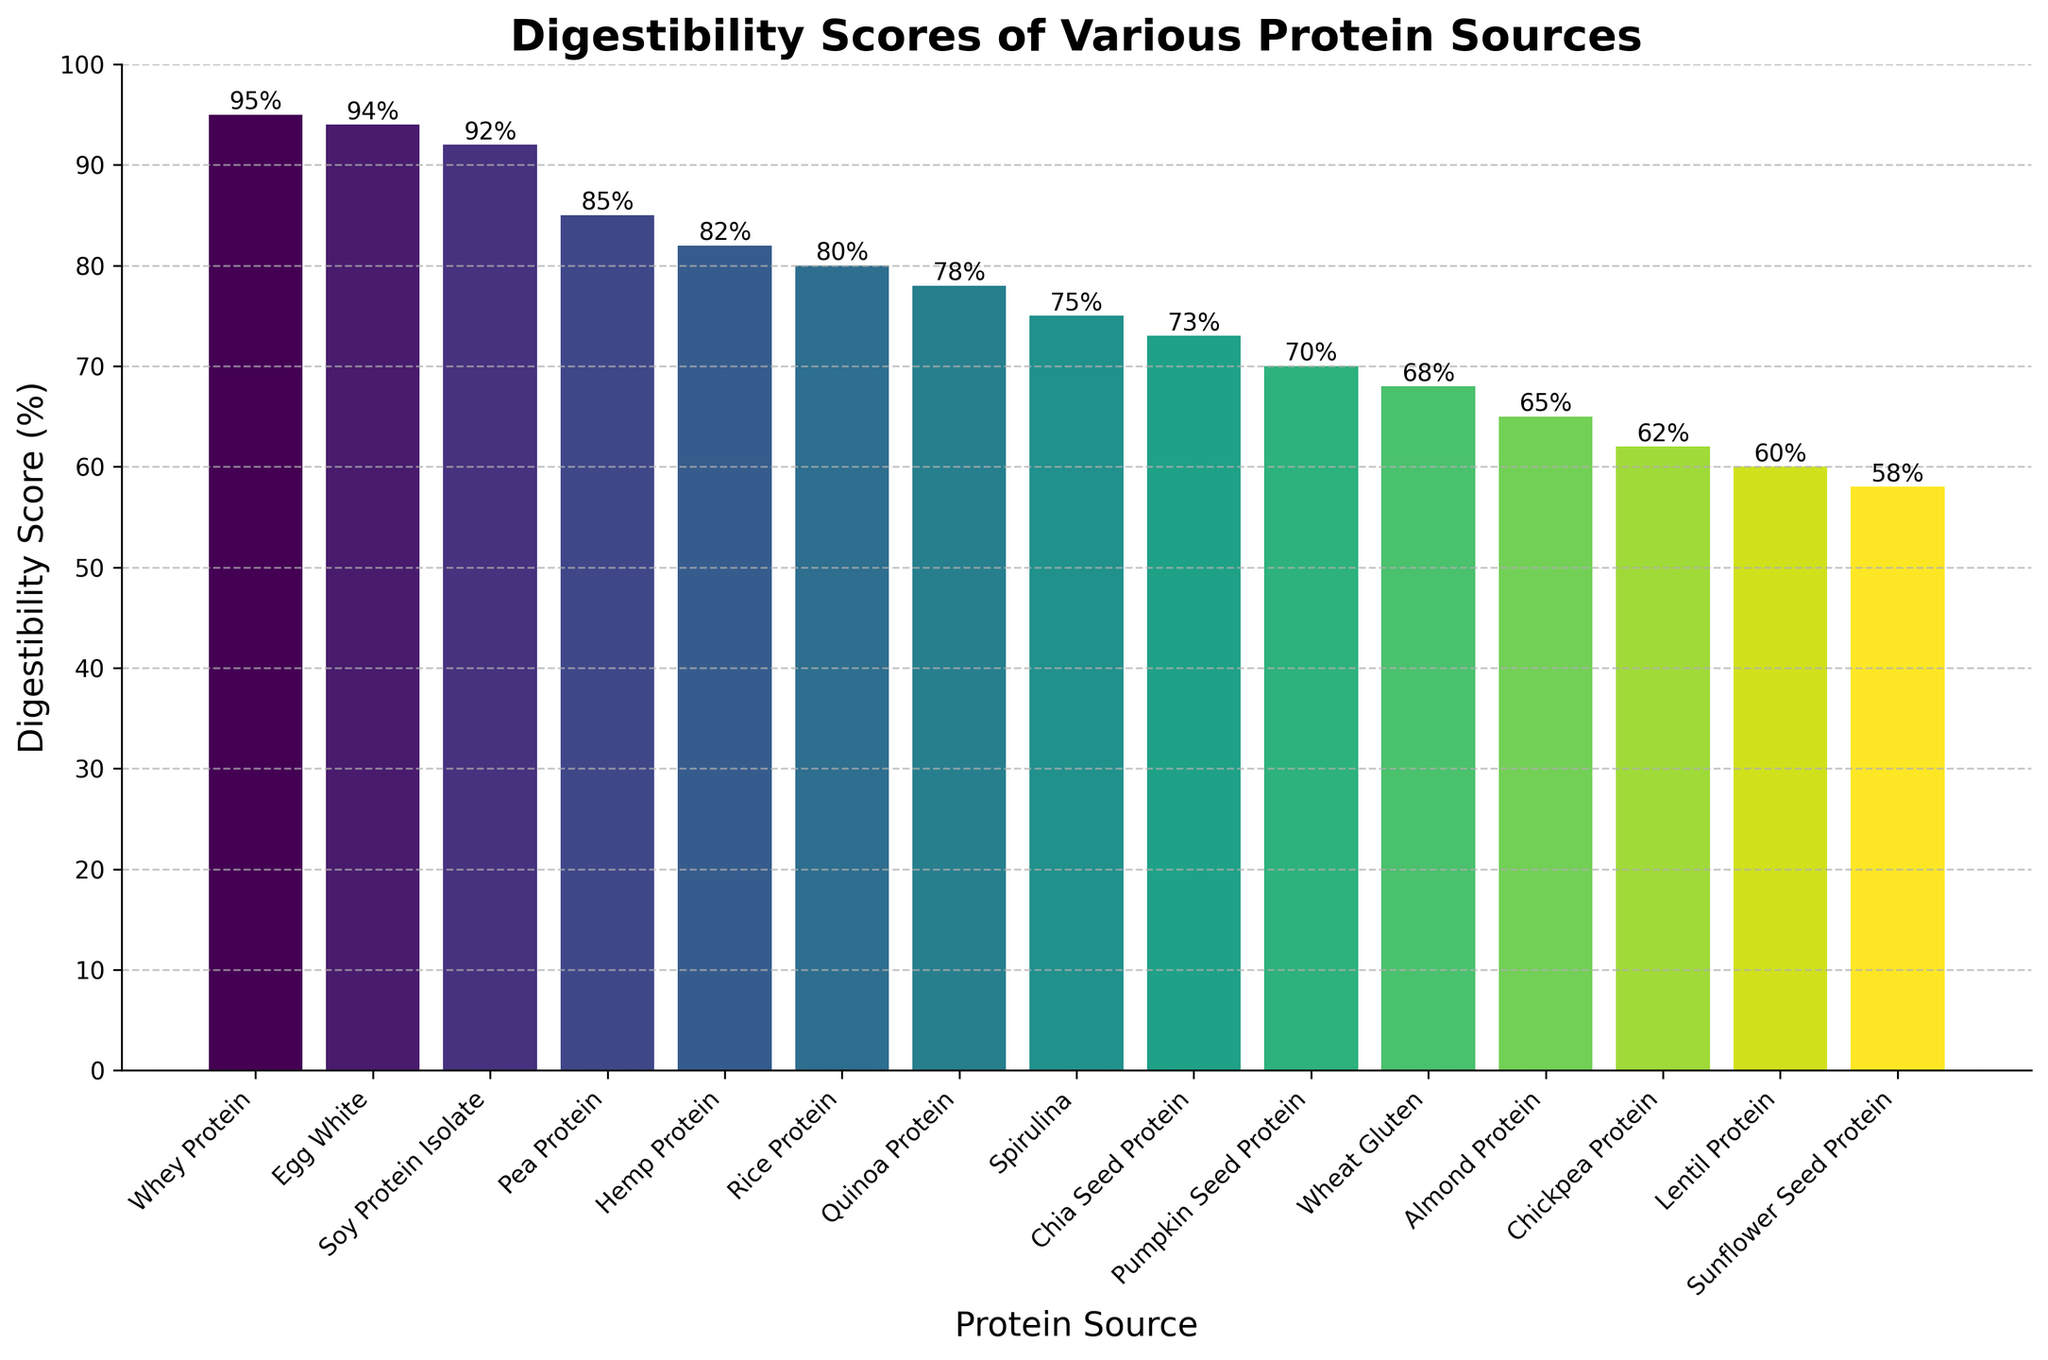Which protein source has the highest digestibility score? From the figure, identify the tallest bar, which represents the protein source with the highest digestibility score. This protein source is Whey Protein.
Answer: Whey Protein Compare the digestibility scores of Soy Protein Isolate and Pea Protein. Which one is higher and by how much? From the figure, find the bars for Soy Protein Isolate and Pea Protein. Soy Protein Isolate has a digestibility score of 92%, while Pea Protein has a score of 85%. Subtract 85 from 92 to find the difference.
Answer: Soy Protein Isolate by 7% What's the average digestibility score of the top five plant-based proteins? The top five plant-based proteins are Soy Protein Isolate (92%), Pea Protein (85%), Hemp Protein (82%), Rice Protein (80%), and Quinoa Protein (78%). Sum the scores and divide by 5: (92 + 85 + 82 + 80 + 78) / 5 = 83.4%
Answer: 83.4% Is the digestibility score of Egg White higher or lower than Rice Protein, and by how much? Identify the bars for Egg White and Rice Protein. Egg White has a digestibility score of 94%, and Rice Protein has a score of 80%. Subtract 80 from 94 to find the difference.
Answer: Higher by 14% Which plant-based protein has the lowest digestibility score and what is it? From the figure, identify the shortest bar representing the lowest digestibility score among plant-based proteins. This protein source is Sunflower Seed Protein with a score of 58%.
Answer: Sunflower Seed Protein, 58% What is the combined digestibility score of Quinoa Protein and Chia Seed Protein? Identify the bars for Quinoa Protein and Chia Seed Protein. Quinoa Protein has a score of 78%, and Chia Seed Protein has a score of 73%. Sum the scores: 78 + 73 = 151%.
Answer: 151% How does the digestibility score of Lentil Protein compare to Wheat Gluten? From the figure, find the bars for Lentil Protein and Wheat Gluten. Lentil Protein has a digestibility score of 60%, and Wheat Gluten has a score of 68%. Lentil Protein's score is lower by 8%.
Answer: Lower by 8% What is the range of digestibility scores for the plant-based proteins? The range is the difference between the highest and lowest scores among plant-based proteins. The highest is Soy Protein Isolate (92%), and the lowest is Sunflower Seed Protein (58%). Subtract 58 from 92 to get the range: 92 - 58 = 34%.
Answer: 34% Which protein source has almost the same digestibility score as Spirulina? Identify the bar for Spirulina, which has a score of 75%, and find the bar with a close score. Chia Seed Protein has a score of 73%, which is close to 75%.
Answer: Chia Seed Protein Is the digestibility score of Pumpkin Seed Protein higher or lower than Quinoa Protein, and by how much? Identify the bars for Pumpkin Seed Protein and Quinoa Protein. Pumpkin Seed Protein has a score of 70%, and Quinoa Protein has a score of 78%. Subtract 70 from 78 to find the difference.
Answer: Lower by 8% 